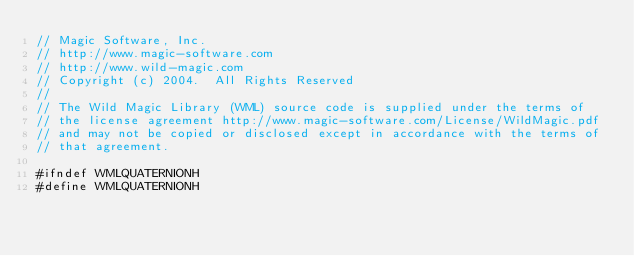Convert code to text. <code><loc_0><loc_0><loc_500><loc_500><_C_>// Magic Software, Inc.
// http://www.magic-software.com
// http://www.wild-magic.com
// Copyright (c) 2004.  All Rights Reserved
//
// The Wild Magic Library (WML) source code is supplied under the terms of
// the license agreement http://www.magic-software.com/License/WildMagic.pdf
// and may not be copied or disclosed except in accordance with the terms of
// that agreement.

#ifndef WMLQUATERNIONH
#define WMLQUATERNIONH</code> 